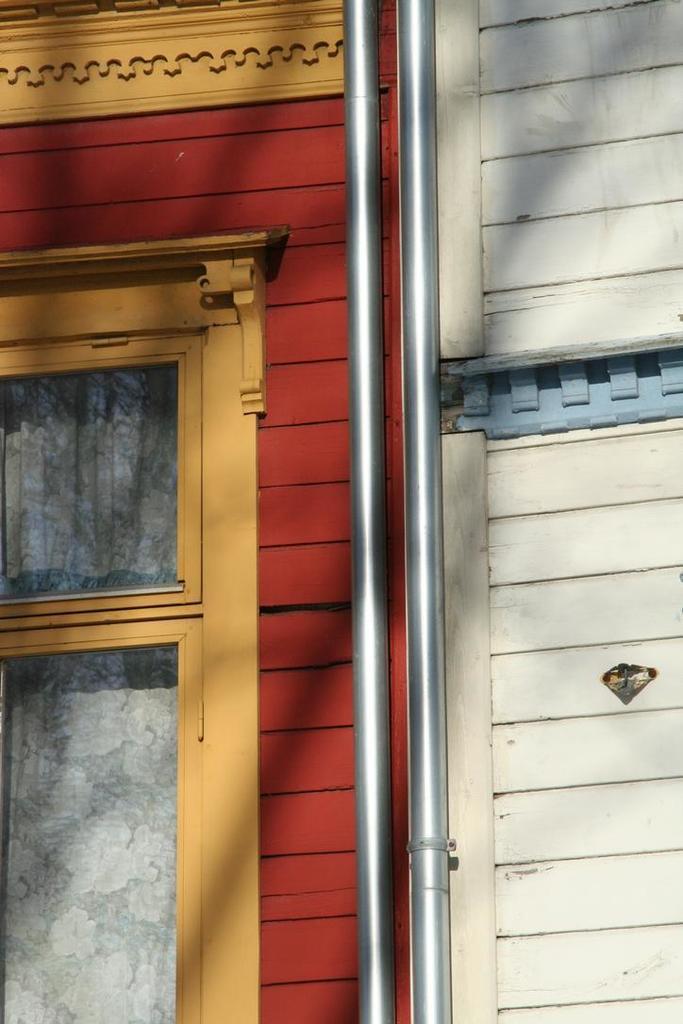Could you give a brief overview of what you see in this image? In this image we can see there is the wall with a design and there is the window, through the window we can see the curtain and there are rods attached to the wall. 